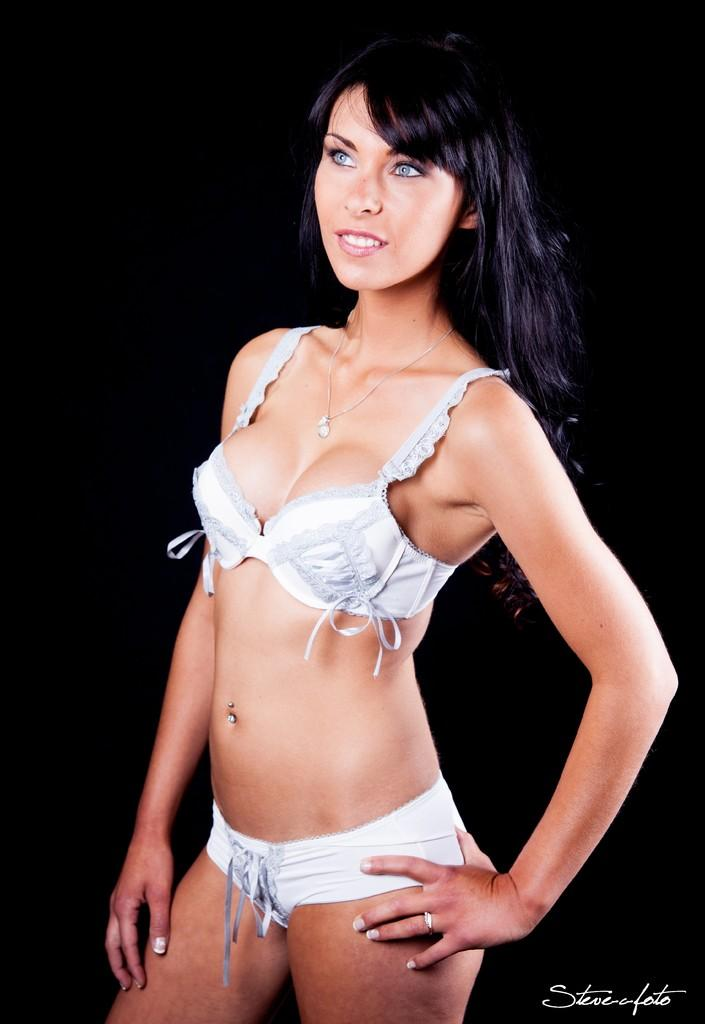What is the main subject of the image? There is a woman standing in the image. How would you describe the background of the image? The background of the image is dark. Is there any additional information or markings on the image? Yes, there is a watermark on the image. What advice does the woman give to the dog wearing a collar in the image? There is no dog wearing a collar in the image, nor is there any advice being given. 